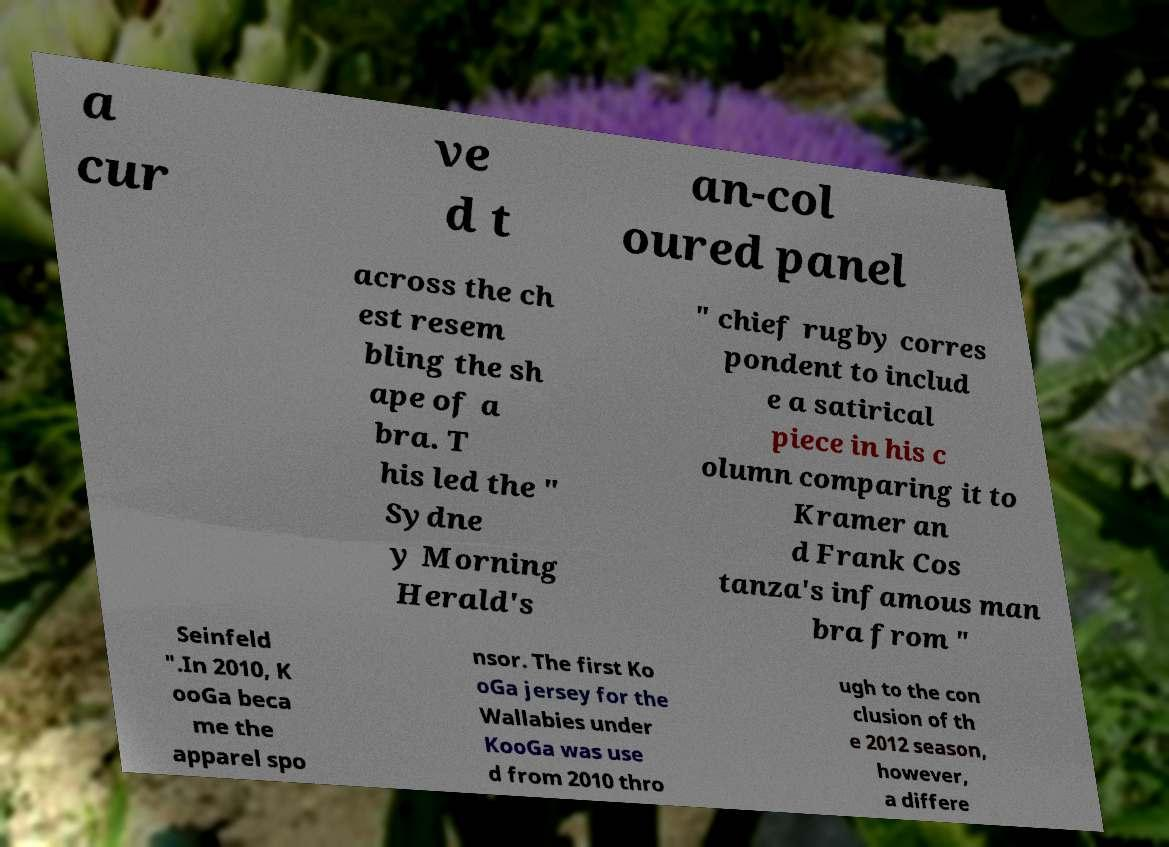Can you accurately transcribe the text from the provided image for me? a cur ve d t an-col oured panel across the ch est resem bling the sh ape of a bra. T his led the " Sydne y Morning Herald's " chief rugby corres pondent to includ e a satirical piece in his c olumn comparing it to Kramer an d Frank Cos tanza's infamous man bra from " Seinfeld ".In 2010, K ooGa beca me the apparel spo nsor. The first Ko oGa jersey for the Wallabies under KooGa was use d from 2010 thro ugh to the con clusion of th e 2012 season, however, a differe 